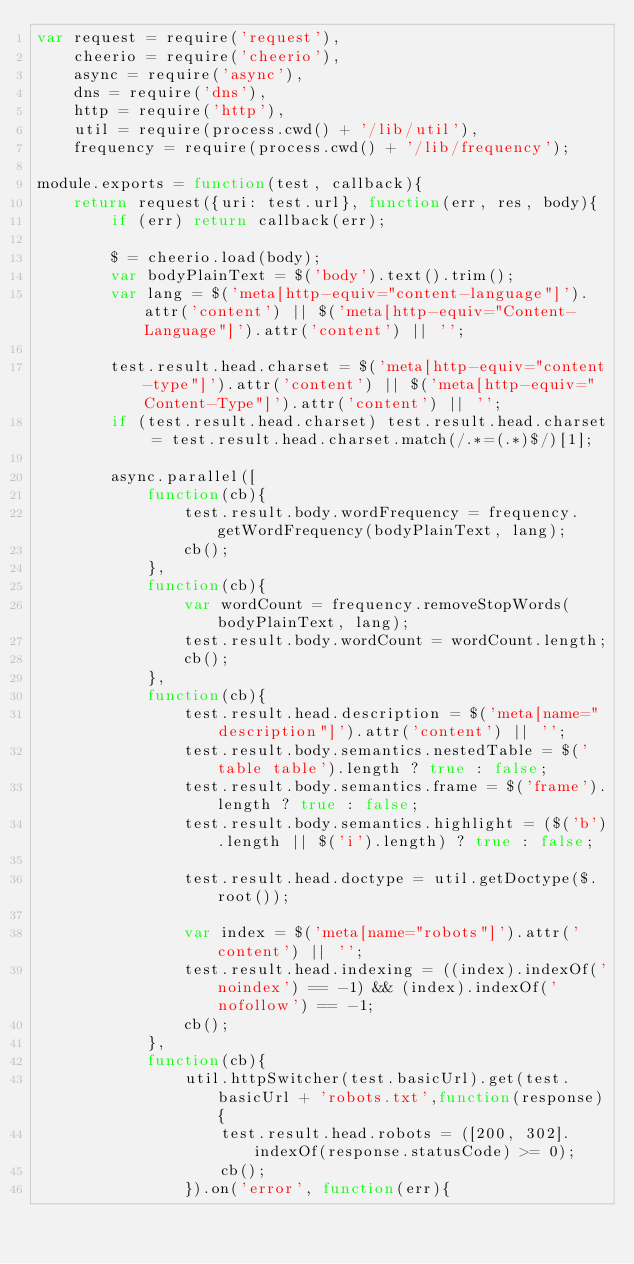<code> <loc_0><loc_0><loc_500><loc_500><_JavaScript_>var request = require('request'),
    cheerio = require('cheerio'),
    async = require('async'),
    dns = require('dns'),
    http = require('http'),
    util = require(process.cwd() + '/lib/util'),
    frequency = require(process.cwd() + '/lib/frequency');

module.exports = function(test, callback){
    return request({uri: test.url}, function(err, res, body){
        if (err) return callback(err);

        $ = cheerio.load(body);
        var bodyPlainText = $('body').text().trim();
        var lang = $('meta[http-equiv="content-language"]').attr('content') || $('meta[http-equiv="Content-Language"]').attr('content') || '';

        test.result.head.charset = $('meta[http-equiv="content-type"]').attr('content') || $('meta[http-equiv="Content-Type"]').attr('content') || '';
        if (test.result.head.charset) test.result.head.charset = test.result.head.charset.match(/.*=(.*)$/)[1];

        async.parallel([
            function(cb){
                test.result.body.wordFrequency = frequency.getWordFrequency(bodyPlainText, lang);
                cb();
            },
            function(cb){
                var wordCount = frequency.removeStopWords(bodyPlainText, lang);
                test.result.body.wordCount = wordCount.length;
                cb();
            },
            function(cb){
                test.result.head.description = $('meta[name="description"]').attr('content') || '';
                test.result.body.semantics.nestedTable = $('table table').length ? true : false;
                test.result.body.semantics.frame = $('frame').length ? true : false;
                test.result.body.semantics.highlight = ($('b').length || $('i').length) ? true : false;

                test.result.head.doctype = util.getDoctype($.root());

                var index = $('meta[name="robots"]').attr('content') || '';
                test.result.head.indexing = ((index).indexOf('noindex') == -1) && (index).indexOf('nofollow') == -1;
                cb();
            },
            function(cb){
                util.httpSwitcher(test.basicUrl).get(test.basicUrl + 'robots.txt',function(response){
                    test.result.head.robots = ([200, 302].indexOf(response.statusCode) >= 0);
                    cb();
                }).on('error', function(err){</code> 